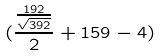Convert formula to latex. <formula><loc_0><loc_0><loc_500><loc_500>( \frac { \frac { 1 9 2 } { \sqrt { 3 9 2 } } } { 2 } + 1 5 9 - 4 )</formula> 